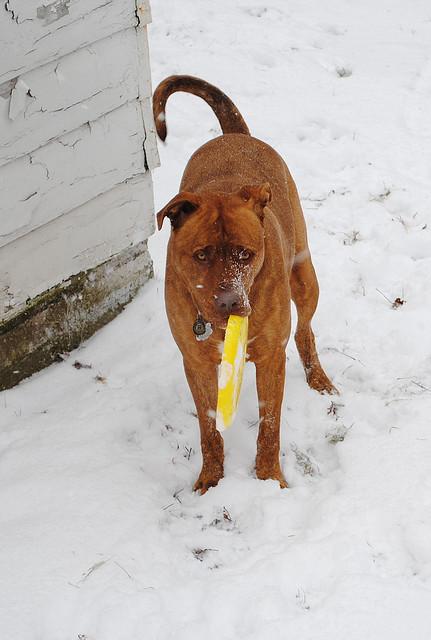What does the dog have in its mouth?
Concise answer only. Frisbee. Does the dog look cold?
Write a very short answer. Yes. What's it like to play in the snow?
Answer briefly. Fun. 